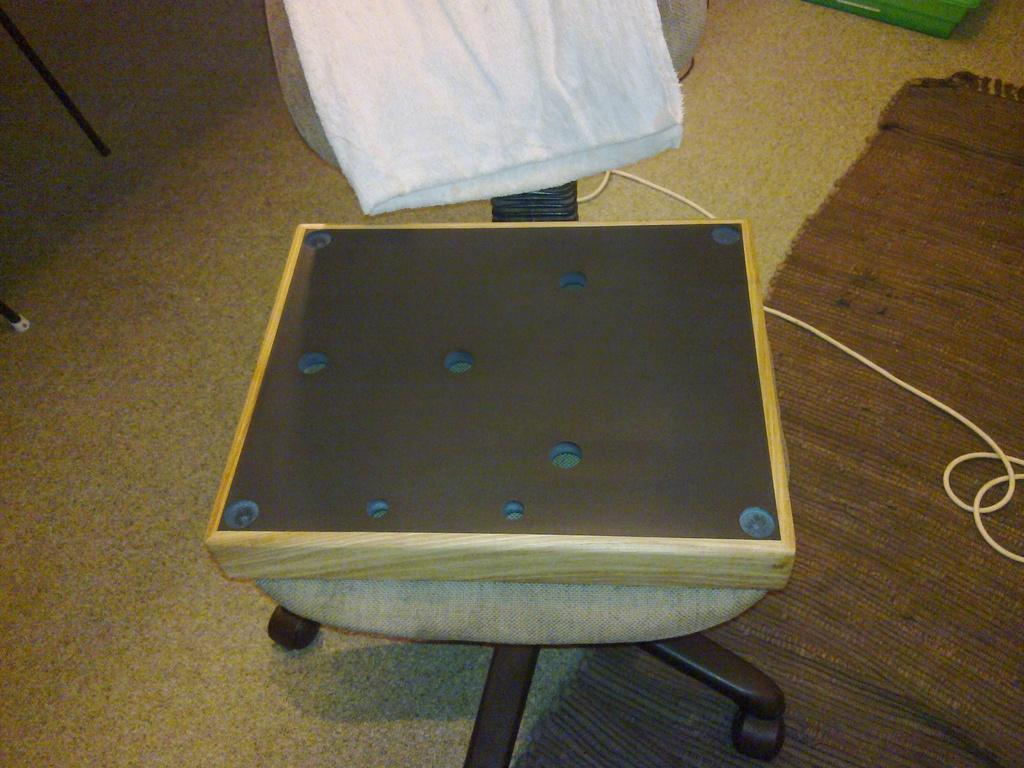What type of furniture is in the image? There is a chair in the image. What is covering the chair? There is a cloth on the chair. What is placed on top of the cloth? There is a box on the chair. What is located at the bottom of the image? There is a mat and a wire at the bottom of the image. What type of weather can be seen in the image? There is no weather depicted in the image; it is a still image of a chair, cloth, box, mat, and wire. 